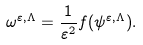Convert formula to latex. <formula><loc_0><loc_0><loc_500><loc_500>\omega ^ { \varepsilon , \Lambda } = \frac { 1 } { \varepsilon ^ { 2 } } f ( \psi ^ { \varepsilon , \Lambda } ) .</formula> 